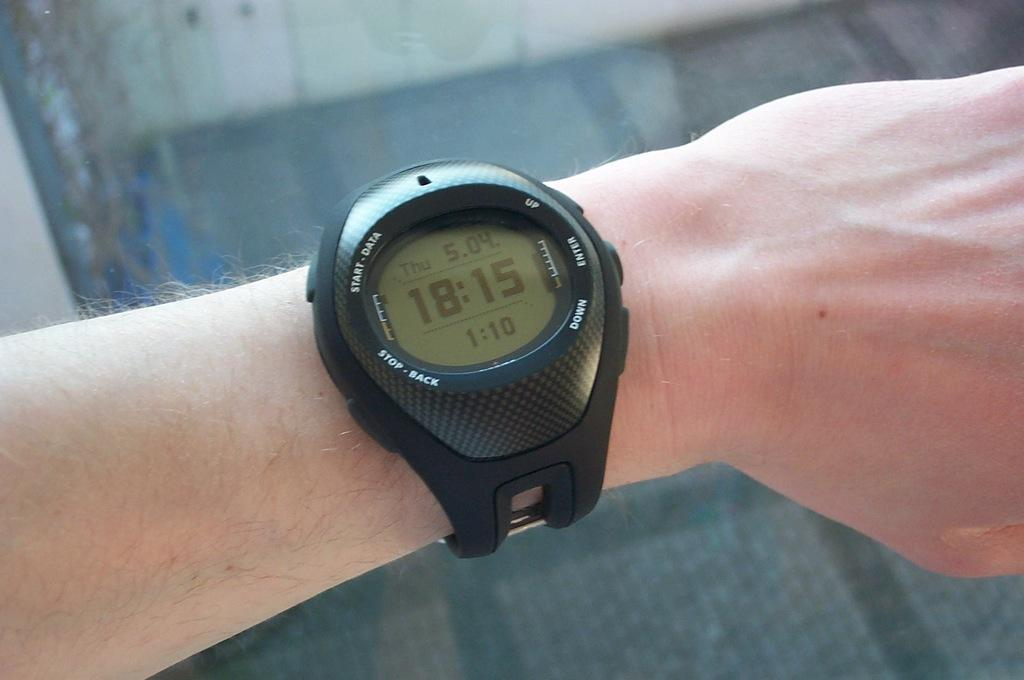<image>
Present a compact description of the photo's key features. Person wearing a watch with the time 18:15 on it. 